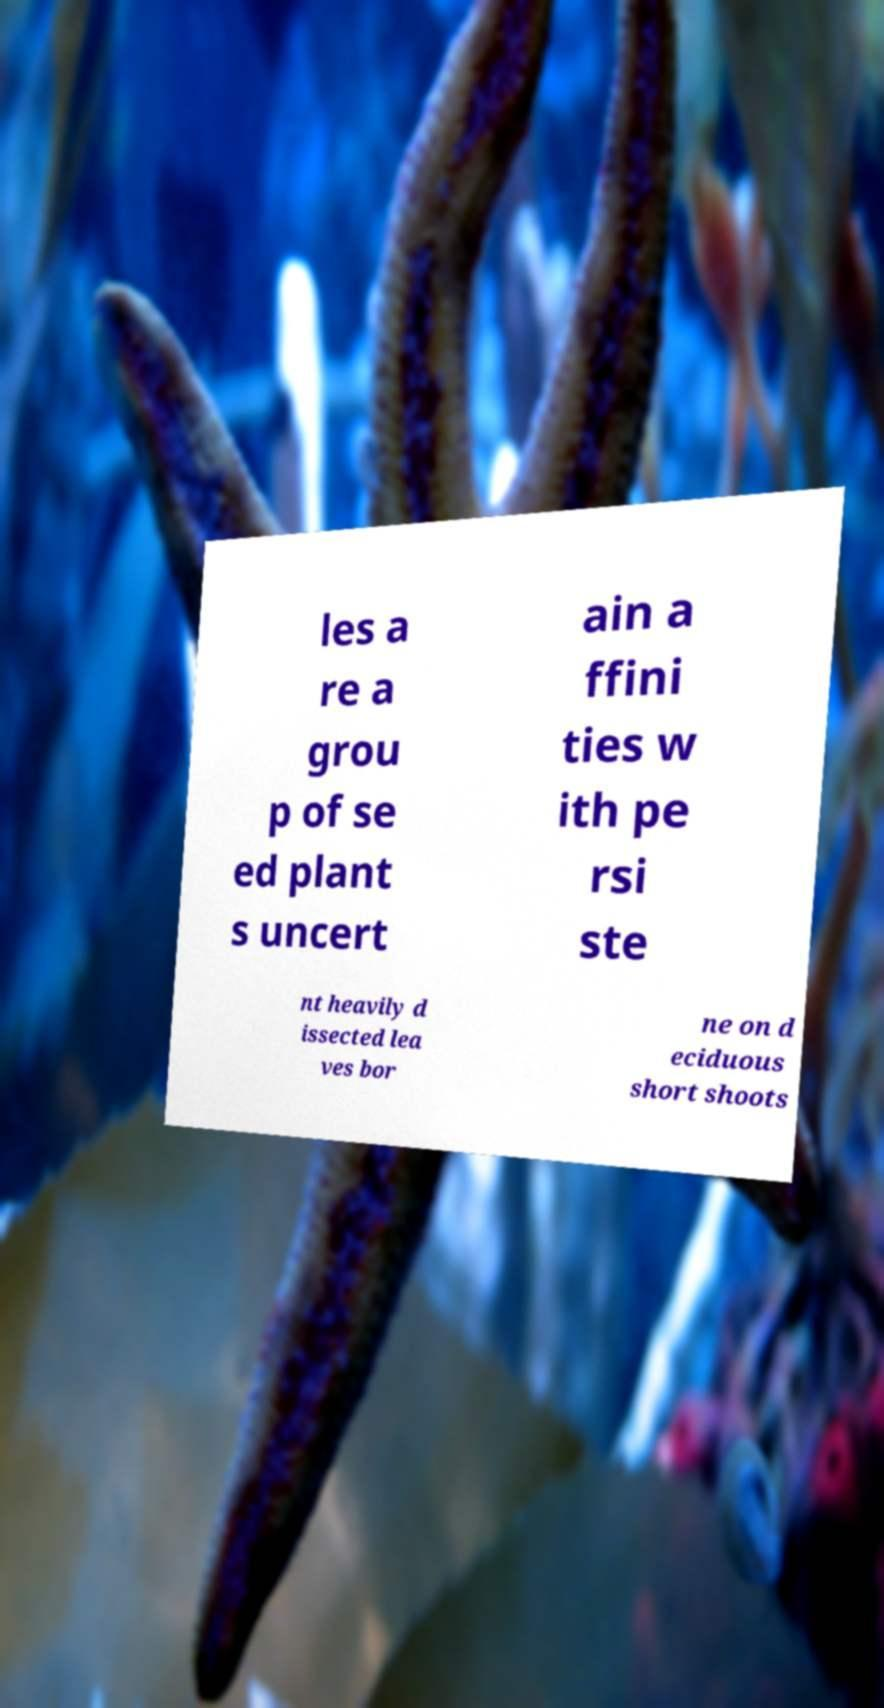Can you accurately transcribe the text from the provided image for me? les a re a grou p of se ed plant s uncert ain a ffini ties w ith pe rsi ste nt heavily d issected lea ves bor ne on d eciduous short shoots 